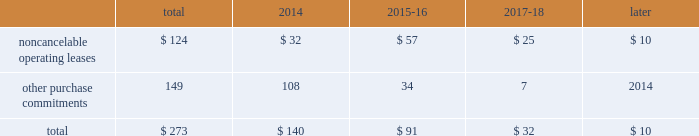23t .
Rowe price group | annual report 2013 contractual obligations the table presents a summary of our future obligations ( in millions ) under the terms of existing operating leases and other contractual cash purchase commitments at december 31 , 2013 .
Other purchase commitments include contractual amounts that will be due for the purchase of goods or services to be used in our operations and may be cancelable at earlier times than those indicated , under certain conditions that may involve termination fees .
Because these obligations are generally of a normal recurring nature , we expect that we will fund them from future cash flows from operations .
The information presented does not include operating expenses or capital expenditures that will be committed in the normal course of operations in 2014 and future years .
The information also excludes the $ 4.8 million of uncertain tax positions discussed in note 8 to our consolidated financial statements because it is not possible to estimate the time period in which a payment might be made to the tax authorities. .
We also have outstanding commitments to fund additional contributions to investment partnerships totaling $ 40.7 million at december 31 , 2013 .
The vast majority of these additional contributions will be made to investment partnerships in which we have an existing investment .
In addition to such amounts , a percentage of prior distributions may be called under certain circumstances .
In january 2014 , we renewed and extended our operating lease at our corporate headquarters in baltimore , maryland through 2027 .
This lease agreement increases the above disclosed total noncancelable operating lease commitments by an additional $ 133.0 million , the vast majority of which will be paid after 2018 .
Critical accounting policies the preparation of financial statements often requires the selection of specific accounting methods and policies from among several acceptable alternatives .
Further , significant estimates and judgments may be required in selecting and applying those methods and policies in the recognition of the assets and liabilities in our consolidated balance sheets , the revenues and expenses in our consolidated statements of income , and the information that is contained in our significant accounting policies and notes to consolidated financial statements .
Making these estimates and judgments requires the analysis of information concerning events that may not yet be complete and of facts and circumstances that may change over time .
Accordingly , actual amounts or future results can differ materially from those estimates that we include currently in our consolidated financial statements , significant accounting policies , and notes .
We present those significant accounting policies used in the preparation of our consolidated financial statements as an integral part of those statements within this 2013 annual report .
In the following discussion , we highlight and explain further certain of those policies that are most critical to the preparation and understanding of our financial statements .
Other-than-temporary impairments of available-for-sale securities .
We generally classify our investment holdings in sponsored funds as available-for-sale if we are not deemed to a have a controlling financial interest .
At the end of each quarter , we mark the carrying amount of each investment holding to fair value and recognize an unrealized gain or loss as a component of comprehensive income within the consolidated statements of comprehensive income .
We next review each individual security position that has an unrealized loss or impairment to determine if that impairment is other than temporary .
In determining whether a mutual fund holding is other-than-temporarily impaired , we consider many factors , including the duration of time it has existed , the severity of the impairment , any subsequent changes in value , and our intent and ability to hold the security for a period of time sufficient for an anticipated recovery in fair value .
Subject to the other considerations noted above , we believe a fund holding with an unrealized loss that has persisted daily throughout the six months between quarter-ends is generally presumed to have an other-than-temporary impairment .
We may also recognize an other-than-temporary loss of less than six months in our consolidated statements of income if the particular circumstances of the underlying investment do not warrant our belief that a near-term recovery is possible. .
What percent of the total future obligations in 2014 are from other purchase commitments? 
Computations: (149 / 273)
Answer: 0.54579. 